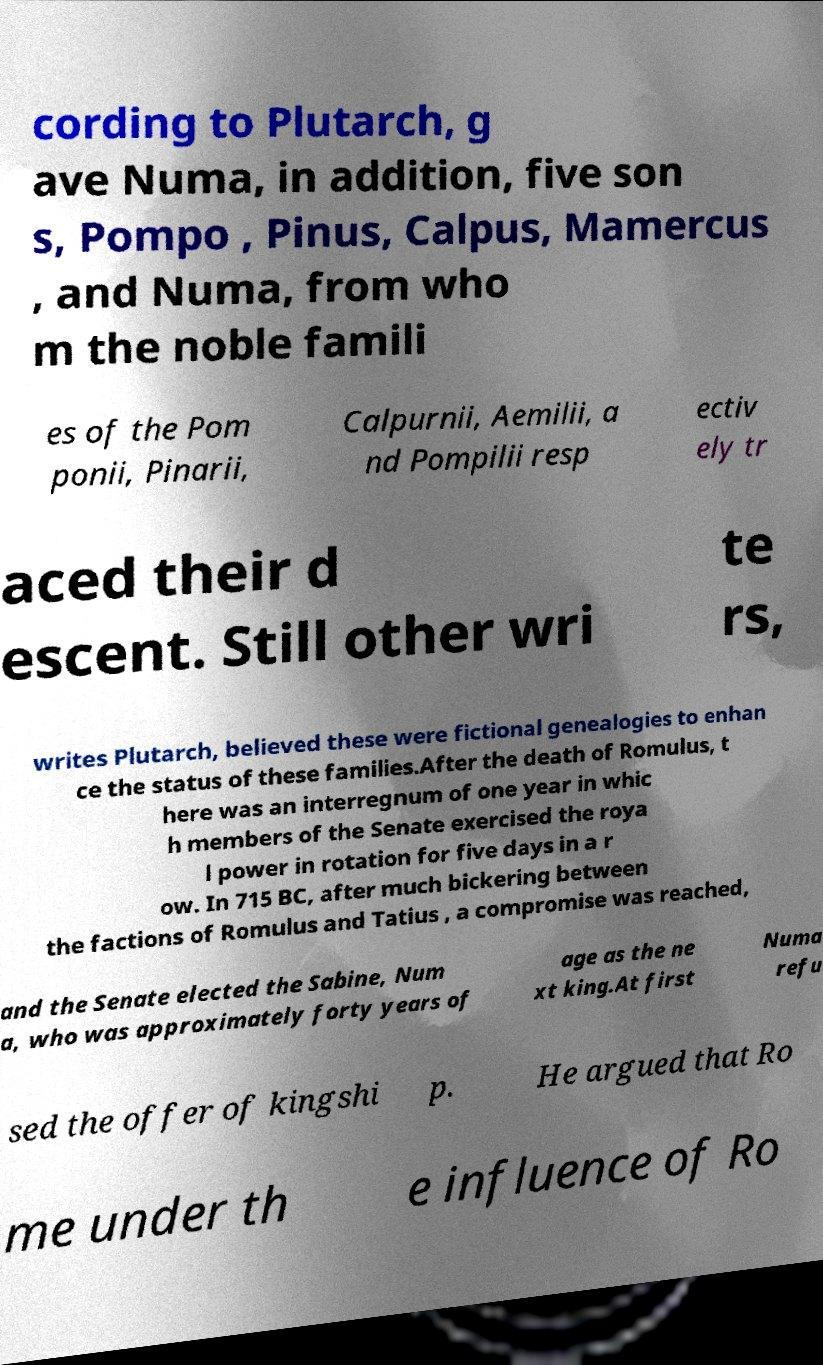Can you read and provide the text displayed in the image?This photo seems to have some interesting text. Can you extract and type it out for me? cording to Plutarch, g ave Numa, in addition, five son s, Pompo , Pinus, Calpus, Mamercus , and Numa, from who m the noble famili es of the Pom ponii, Pinarii, Calpurnii, Aemilii, a nd Pompilii resp ectiv ely tr aced their d escent. Still other wri te rs, writes Plutarch, believed these were fictional genealogies to enhan ce the status of these families.After the death of Romulus, t here was an interregnum of one year in whic h members of the Senate exercised the roya l power in rotation for five days in a r ow. In 715 BC, after much bickering between the factions of Romulus and Tatius , a compromise was reached, and the Senate elected the Sabine, Num a, who was approximately forty years of age as the ne xt king.At first Numa refu sed the offer of kingshi p. He argued that Ro me under th e influence of Ro 